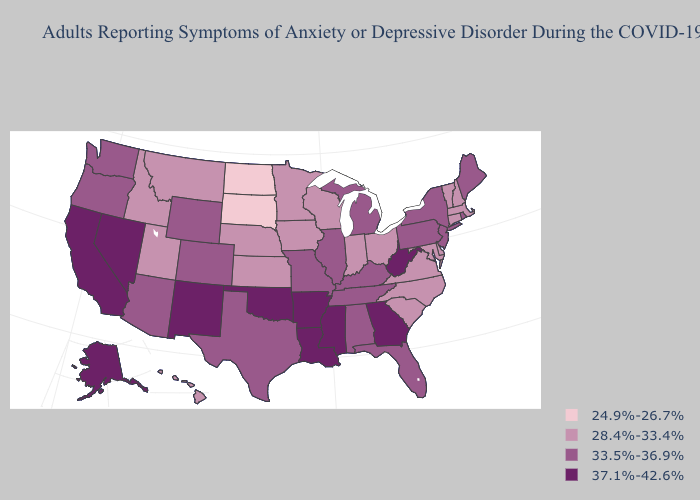Among the states that border Connecticut , does Massachusetts have the lowest value?
Write a very short answer. Yes. What is the highest value in states that border Montana?
Concise answer only. 33.5%-36.9%. Does Wisconsin have a lower value than Massachusetts?
Short answer required. No. Is the legend a continuous bar?
Answer briefly. No. Among the states that border Arizona , does Nevada have the lowest value?
Short answer required. No. Does Nevada have a higher value than Indiana?
Be succinct. Yes. Does South Dakota have a lower value than North Dakota?
Give a very brief answer. No. Name the states that have a value in the range 37.1%-42.6%?
Be succinct. Alaska, Arkansas, California, Georgia, Louisiana, Mississippi, Nevada, New Mexico, Oklahoma, West Virginia. Name the states that have a value in the range 24.9%-26.7%?
Concise answer only. North Dakota, South Dakota. Does West Virginia have the same value as Oklahoma?
Be succinct. Yes. Which states have the lowest value in the South?
Concise answer only. Delaware, Maryland, North Carolina, South Carolina, Virginia. Among the states that border North Carolina , which have the highest value?
Answer briefly. Georgia. Does the first symbol in the legend represent the smallest category?
Short answer required. Yes. Among the states that border Wyoming , does Montana have the lowest value?
Be succinct. No. Name the states that have a value in the range 24.9%-26.7%?
Concise answer only. North Dakota, South Dakota. 